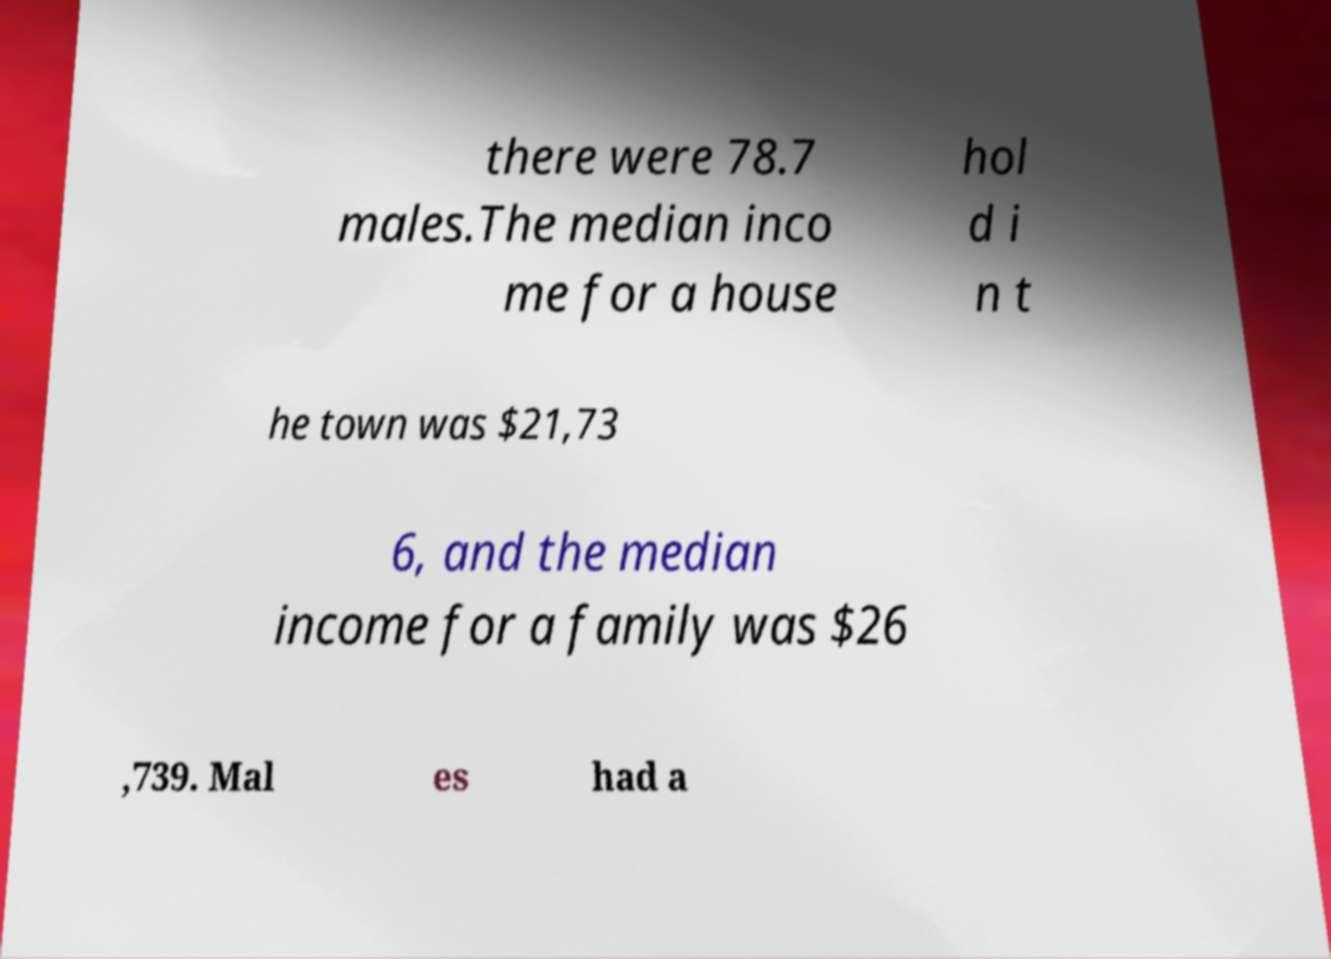For documentation purposes, I need the text within this image transcribed. Could you provide that? there were 78.7 males.The median inco me for a house hol d i n t he town was $21,73 6, and the median income for a family was $26 ,739. Mal es had a 